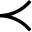Convert formula to latex. <formula><loc_0><loc_0><loc_500><loc_500>\prec</formula> 